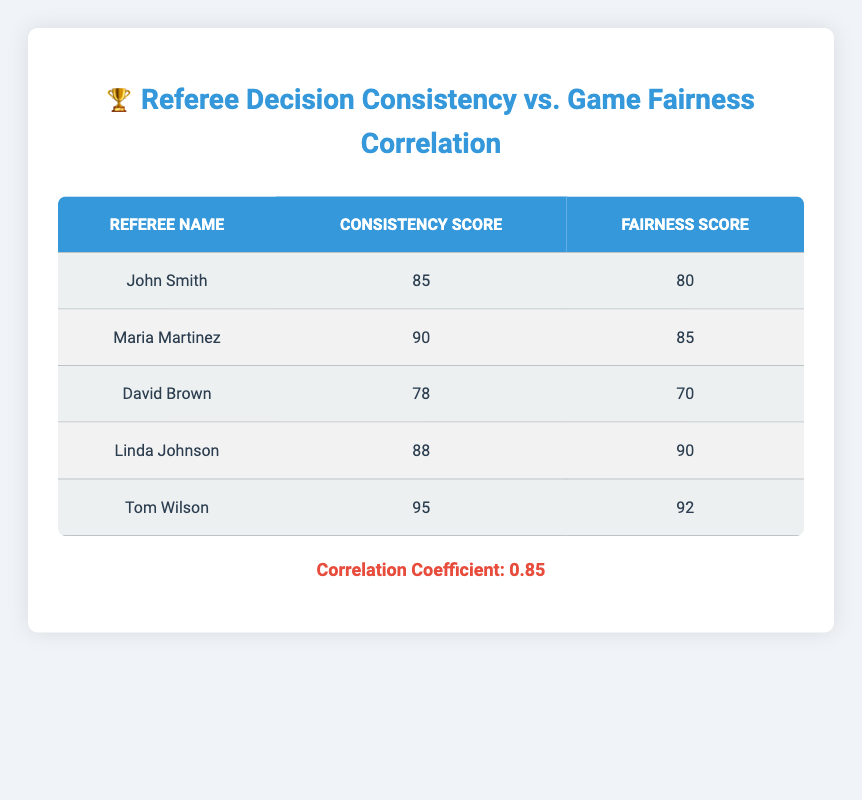What is the Consistency Score for Tom Wilson? The table lists Tom Wilson's Consistency Score directly next to his name. By checking the corresponding row, we see it is 95.
Answer: 95 Which referee has the highest Fairness Score? By examining the Fairness Scores in the table for each referee, Tom Wilson has a score of 92, which is higher than all the others (John Smith: 80, Maria Martinez: 85, David Brown: 70, Linda Johnson: 90).
Answer: Tom Wilson Is the correlation coefficient between Referee Decision Consistency and Game Fairness Ratings positive? The correlation coefficient given in the table is 0.85, which is a positive value indicating a positive correlation.
Answer: Yes What is the average Consistency Score of all referees? To calculate the average, we add all the Consistency Scores (85 + 90 + 78 + 88 + 95 = 436) and then divide by the number of referees (5), resulting in 436 / 5 = 87.2.
Answer: 87.2 Which referee had a Consistency Score lower than 80? Looking at the Consistency Scores, only David Brown has a score of 78, which is less than 80.
Answer: David Brown What is the difference between the highest and lowest Fairness Scores in the table? The highest Fairness Score is 92 (Tom Wilson) and the lowest is 70 (David Brown). The difference is 92 - 70 = 22.
Answer: 22 Are there more referees with a Fairness Score above 85 than below 85? There are three referees with a Fairness Score above 85 (Maria Martinez: 85, Linda Johnson: 90, Tom Wilson: 92) and two below (John Smith: 80, David Brown: 70), so there are more above 85.
Answer: Yes What is the total of the Consistency Scores for referees with a Fairness Score over 85? The referees with a Fairness Score over 85 are Maria Martinez (90), Linda Johnson (90), and Tom Wilson (92). Their Consistency Scores are 90, 88, and 95, respectively. Adding these gives: 90 + 88 + 95 = 273.
Answer: 273 How many referees scored a Fairness Score of 80 or less? Examining the table, John Smith (80) and David Brown (70) are the only referees who scored 80 or below, totaling two referees.
Answer: 2 